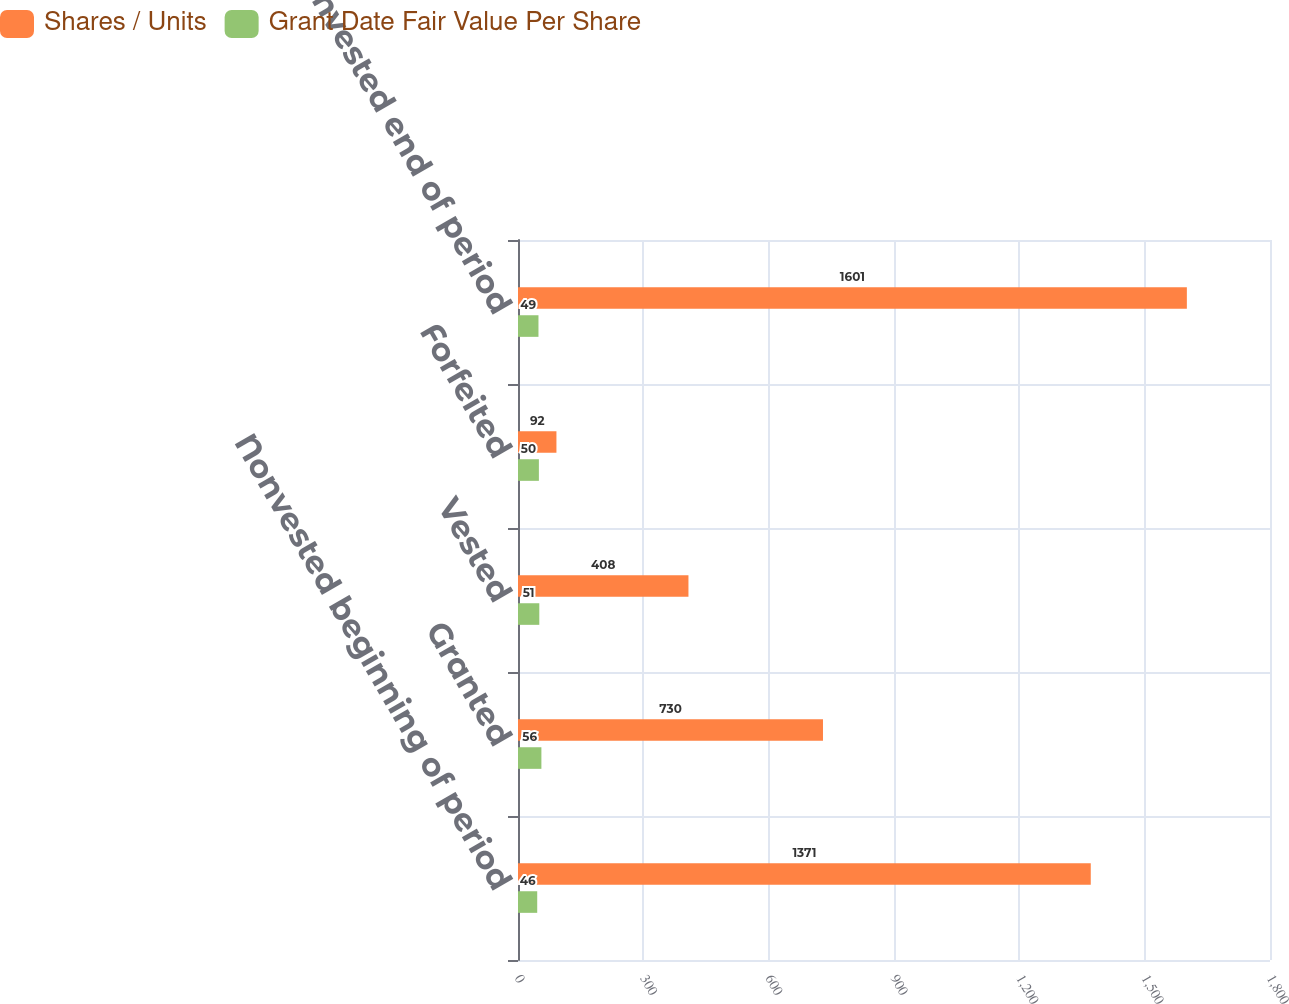Convert chart. <chart><loc_0><loc_0><loc_500><loc_500><stacked_bar_chart><ecel><fcel>Nonvested beginning of period<fcel>Granted<fcel>Vested<fcel>Forfeited<fcel>Nonvested end of period<nl><fcel>Shares / Units<fcel>1371<fcel>730<fcel>408<fcel>92<fcel>1601<nl><fcel>Grant Date Fair Value Per Share<fcel>46<fcel>56<fcel>51<fcel>50<fcel>49<nl></chart> 